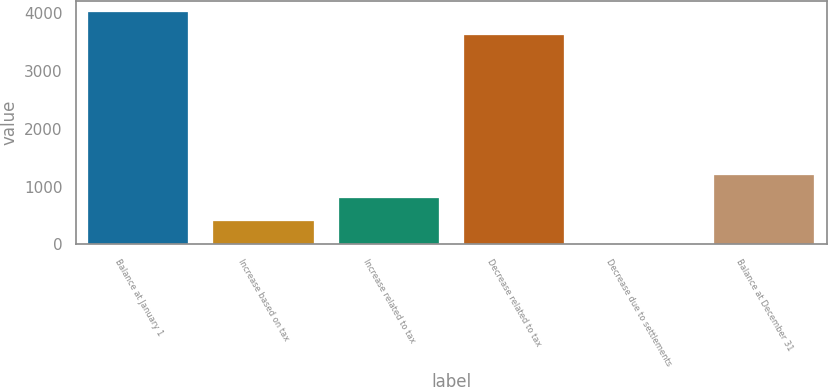<chart> <loc_0><loc_0><loc_500><loc_500><bar_chart><fcel>Balance at January 1<fcel>Increase based on tax<fcel>Increase related to tax<fcel>Decrease related to tax<fcel>Decrease due to settlements<fcel>Balance at December 31<nl><fcel>4005.57<fcel>399.91<fcel>795.48<fcel>3610<fcel>4.34<fcel>1191.05<nl></chart> 